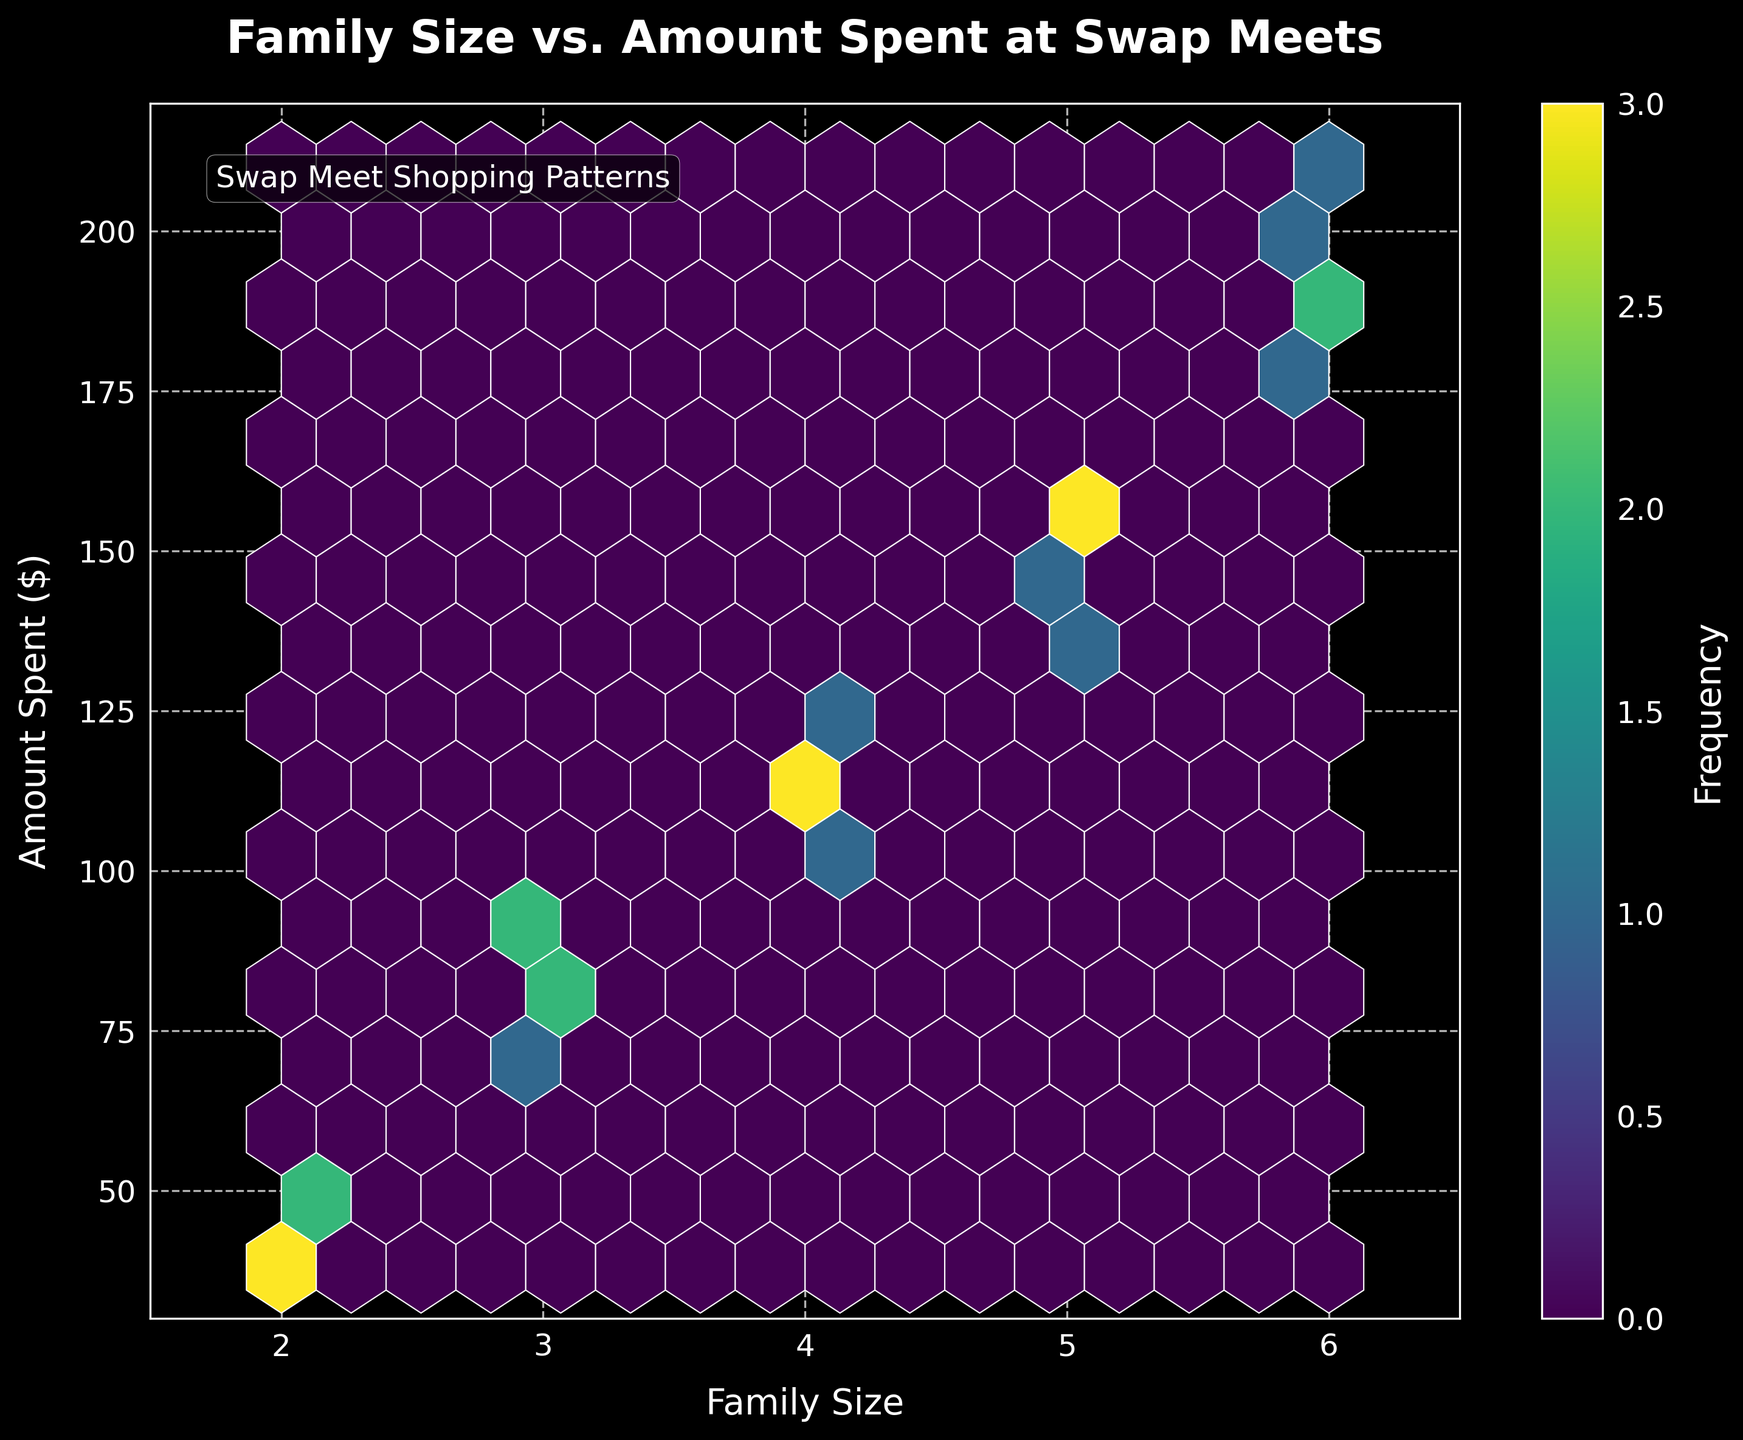What is the title of the plot? The title of the plot is written at the top center of the figure. It is "Family Size vs. Amount Spent at Swap Meets".
Answer: Family Size vs. Amount Spent at Swap Meets What are the labels of the x-axis and y-axis? The labels of the x-axis and y-axis provide information on what each axis represents. The x-axis is labeled "Family Size" and the y-axis is labeled "Amount Spent ($)".
Answer: Family Size and Amount Spent ($) What is the color scheme used in the hexbin plot? The color scheme represents the frequency of data points within each hexbin. It uses the "viridis" colormap, which ranges from shades of yellow to green to purple.
Answer: Viridis Where is the data most densely populated? The density of data points is indicated by the most intense color in the hexbin plot. The area around family sizes of 4 to 5 and amounts spent between $100 and $155 show the highest density.
Answer: Around family sizes of 4 to 5 and $100 to $155 What is indicated by the color bar on the right side of the plot? The color bar shows the frequency of data points within each hexbin. The brighter the color, the higher the number of data points in that bin.
Answer: Frequency of data points Is there a trend visible in the relationship between family size and the amount spent at swap meets? The scatter of the data points and color intensity in the hexbin plot generally show that as the family size increases, the amount spent at swap meets also increases.
Answer: Yes, increasing trend Which family size has the highest maximum amount spent? By looking at the upper parts of the hexbin plot, the family size of 6 has the highest maximum amount spent, which reaches up to $210.
Answer: Family size of 6 What family size appears to spend the least amount on average at swap meets? The color intensity at the lower amount spent values indicates that family size of 2 spends the least on average, with a range below $50.
Answer: Family size of 2 Considering the range provided, what is the approximate average amount spent by families of size 3 at swap meets? Observing the data points for family size 3, the amounts spent range typically between $70 and $92. The approximate average can be estimated around the midpoint of this range.
Answer: Approximately $80 How does the distribution of spending change as the family size increases from 2 to 6? As family size increases, the amount spent also increases and becomes more diverse, spreading out to higher values. The density also shows an increase in the number of higher spending as family sizes grow.
Answer: Spending increases and diversifies as family size increases 